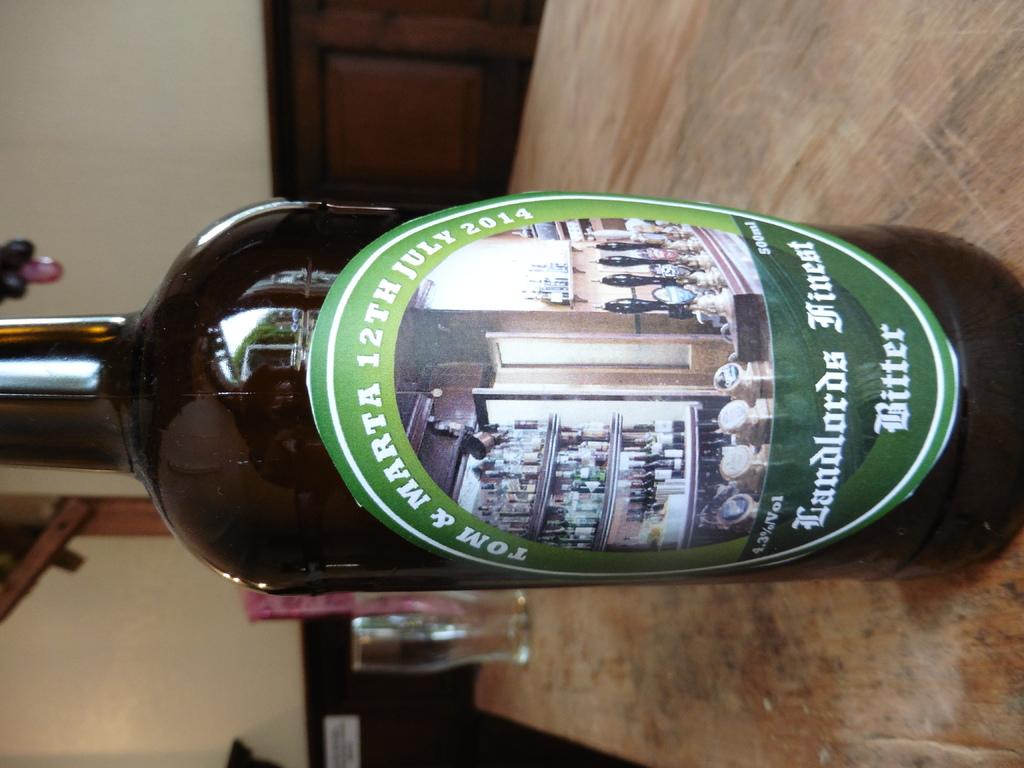<image>
Describe the image concisely. a bottle with a label that says tom & marta 12th july 2014 on it 